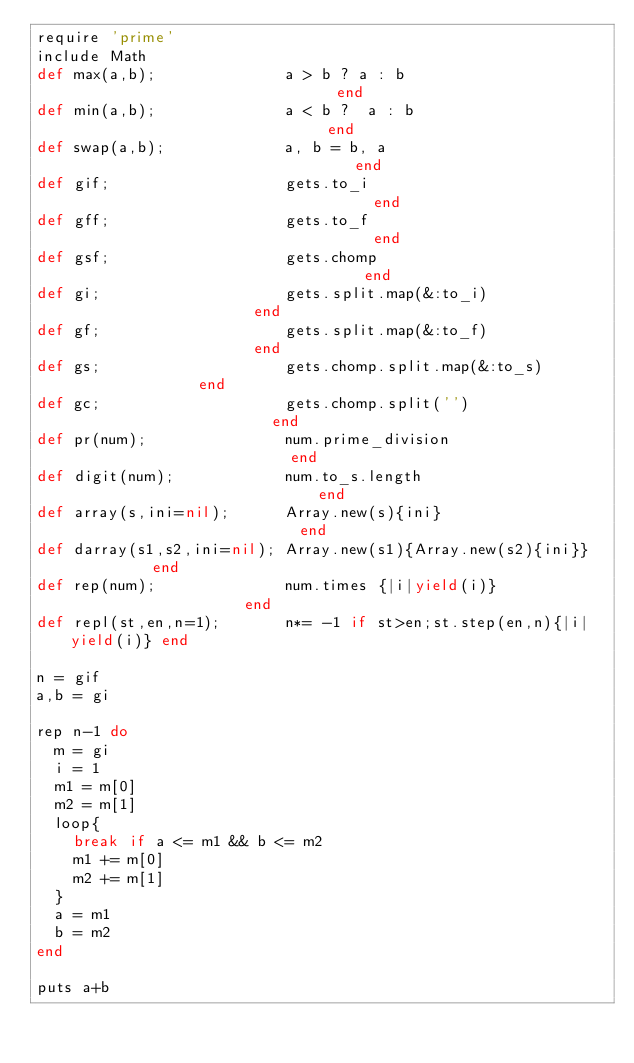Convert code to text. <code><loc_0><loc_0><loc_500><loc_500><_Ruby_>require 'prime'
include Math
def max(a,b);              a > b ? a : b                              end
def min(a,b);              a < b ?  a : b                             end
def swap(a,b);             a, b = b, a                                end
def gif;                   gets.to_i                                  end
def gff;                   gets.to_f                                  end
def gsf;                   gets.chomp                                 end
def gi;                    gets.split.map(&:to_i)                     end
def gf;                    gets.split.map(&:to_f)                     end
def gs;                    gets.chomp.split.map(&:to_s)               end
def gc;                    gets.chomp.split('')                       end
def pr(num);               num.prime_division                         end
def digit(num);            num.to_s.length                            end
def array(s,ini=nil);      Array.new(s){ini}                          end
def darray(s1,s2,ini=nil); Array.new(s1){Array.new(s2){ini}}          end
def rep(num);              num.times {|i|yield(i)}                    end
def repl(st,en,n=1);       n*= -1 if st>en;st.step(en,n){|i|yield(i)} end

n = gif
a,b = gi

rep n-1 do
	m = gi
	i = 1
	m1 = m[0]
	m2 = m[1]
	loop{
		break if a <= m1 && b <= m2
		m1 += m[0] 
		m2 += m[1]
	}
	a = m1
	b = m2
end

puts a+b
</code> 